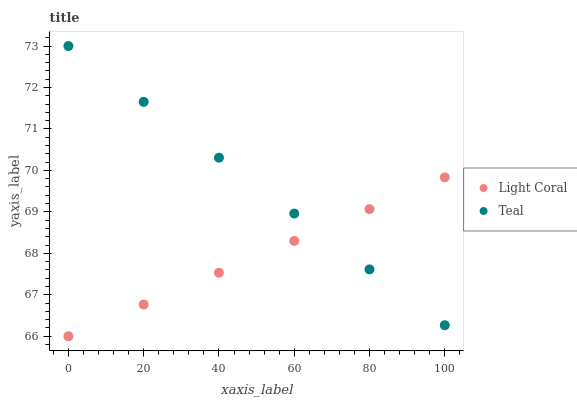Does Light Coral have the minimum area under the curve?
Answer yes or no. Yes. Does Teal have the maximum area under the curve?
Answer yes or no. Yes. Does Teal have the minimum area under the curve?
Answer yes or no. No. Is Light Coral the smoothest?
Answer yes or no. Yes. Is Teal the roughest?
Answer yes or no. Yes. Does Light Coral have the lowest value?
Answer yes or no. Yes. Does Teal have the lowest value?
Answer yes or no. No. Does Teal have the highest value?
Answer yes or no. Yes. Does Light Coral intersect Teal?
Answer yes or no. Yes. Is Light Coral less than Teal?
Answer yes or no. No. Is Light Coral greater than Teal?
Answer yes or no. No. 